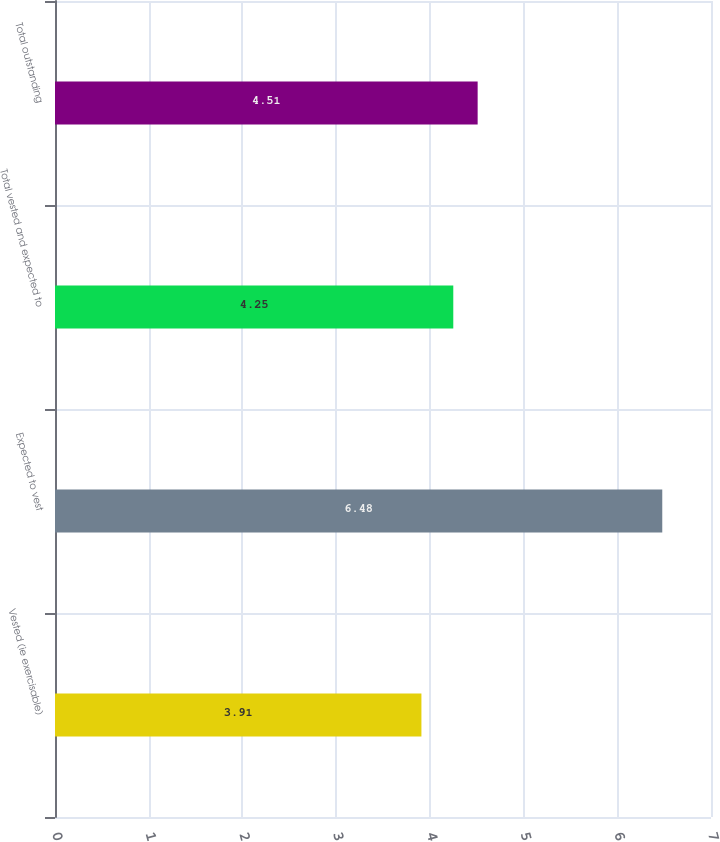<chart> <loc_0><loc_0><loc_500><loc_500><bar_chart><fcel>Vested (ie exercisable)<fcel>Expected to vest<fcel>Total vested and expected to<fcel>Total outstanding<nl><fcel>3.91<fcel>6.48<fcel>4.25<fcel>4.51<nl></chart> 